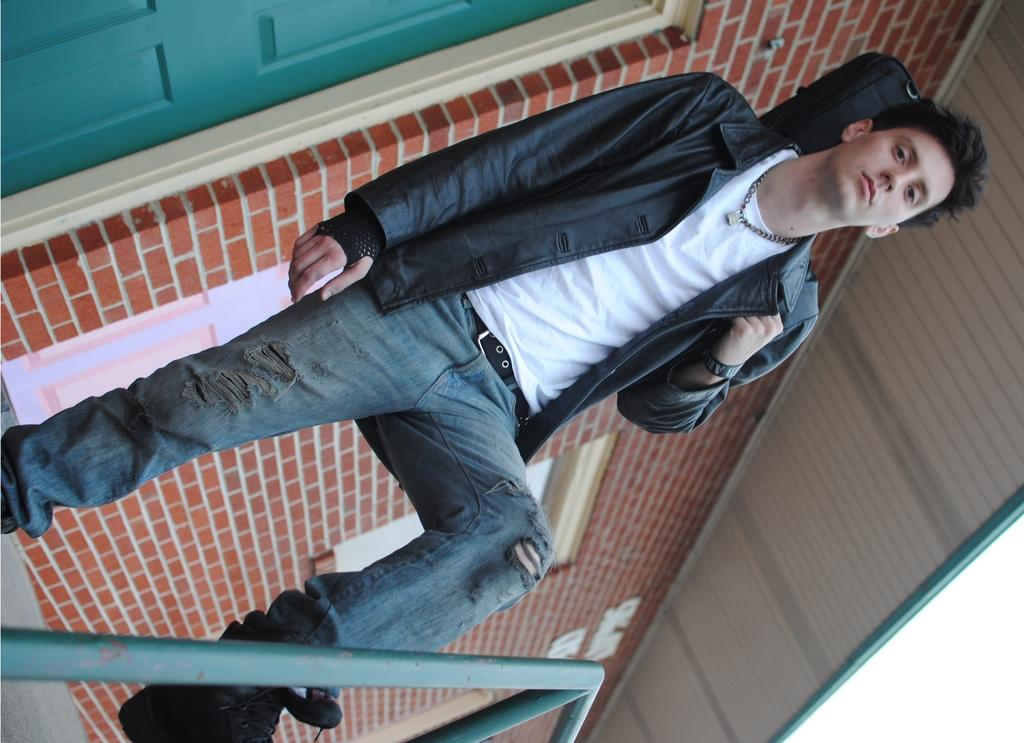What is the main subject of the image? There is a person standing in the image. What structure is visible in the background? There is a building in the image. What features can be observed on the building? The building has windows and a door. What type of meat is being prepared by the person in the image? There is no meat or any indication of food preparation in the image. How many dolls are sitting on the windowsill of the building? There are no dolls present in the image. 